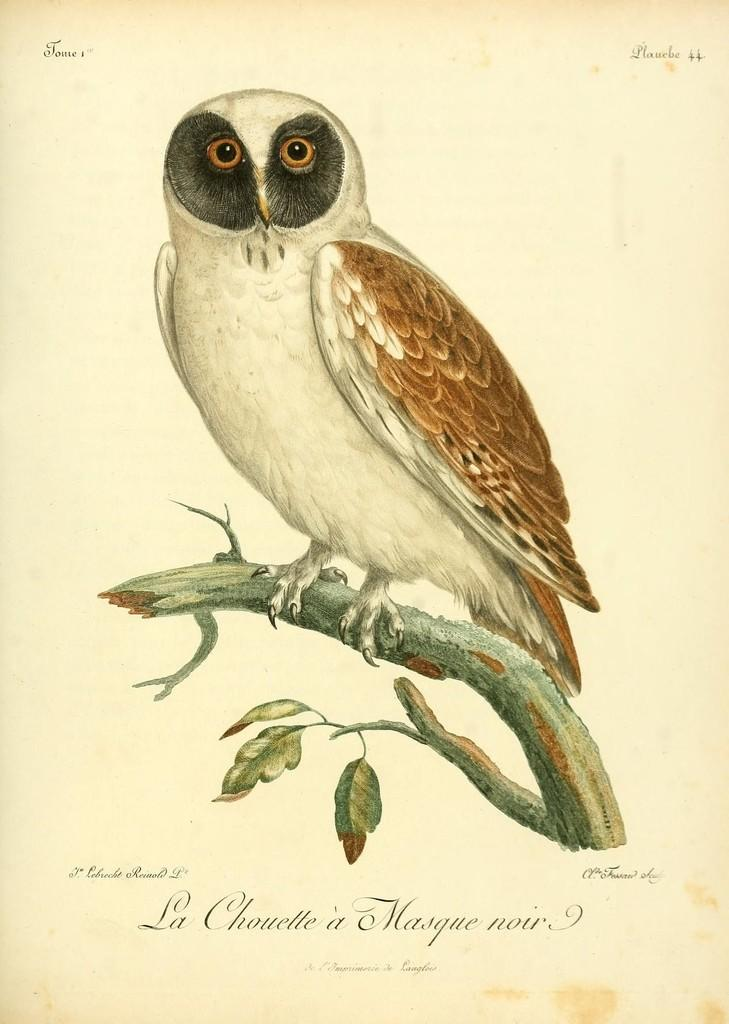What type of animal can be seen in the image? There is an owl in the image. Where is the owl located? The owl is sitting on a tree branch. What else is present in the image besides the owl? There is text in the image, likely on the front cover of a book. What type of jeans is the owl wearing in the image? There are no jeans present in the image, as owls do not wear clothing. 